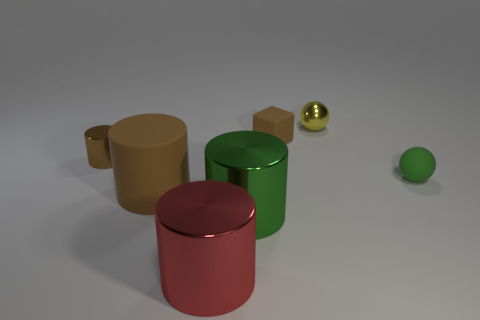Add 3 gray shiny balls. How many objects exist? 10 Subtract all cylinders. How many objects are left? 3 Add 4 small cylinders. How many small cylinders exist? 5 Subtract 2 brown cylinders. How many objects are left? 5 Subtract all yellow metal cylinders. Subtract all brown objects. How many objects are left? 4 Add 3 large shiny objects. How many large shiny objects are left? 5 